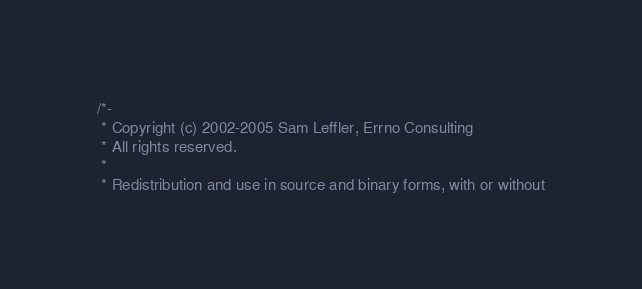Convert code to text. <code><loc_0><loc_0><loc_500><loc_500><_C_>/*-
 * Copyright (c) 2002-2005 Sam Leffler, Errno Consulting
 * All rights reserved.
 *
 * Redistribution and use in source and binary forms, with or without</code> 